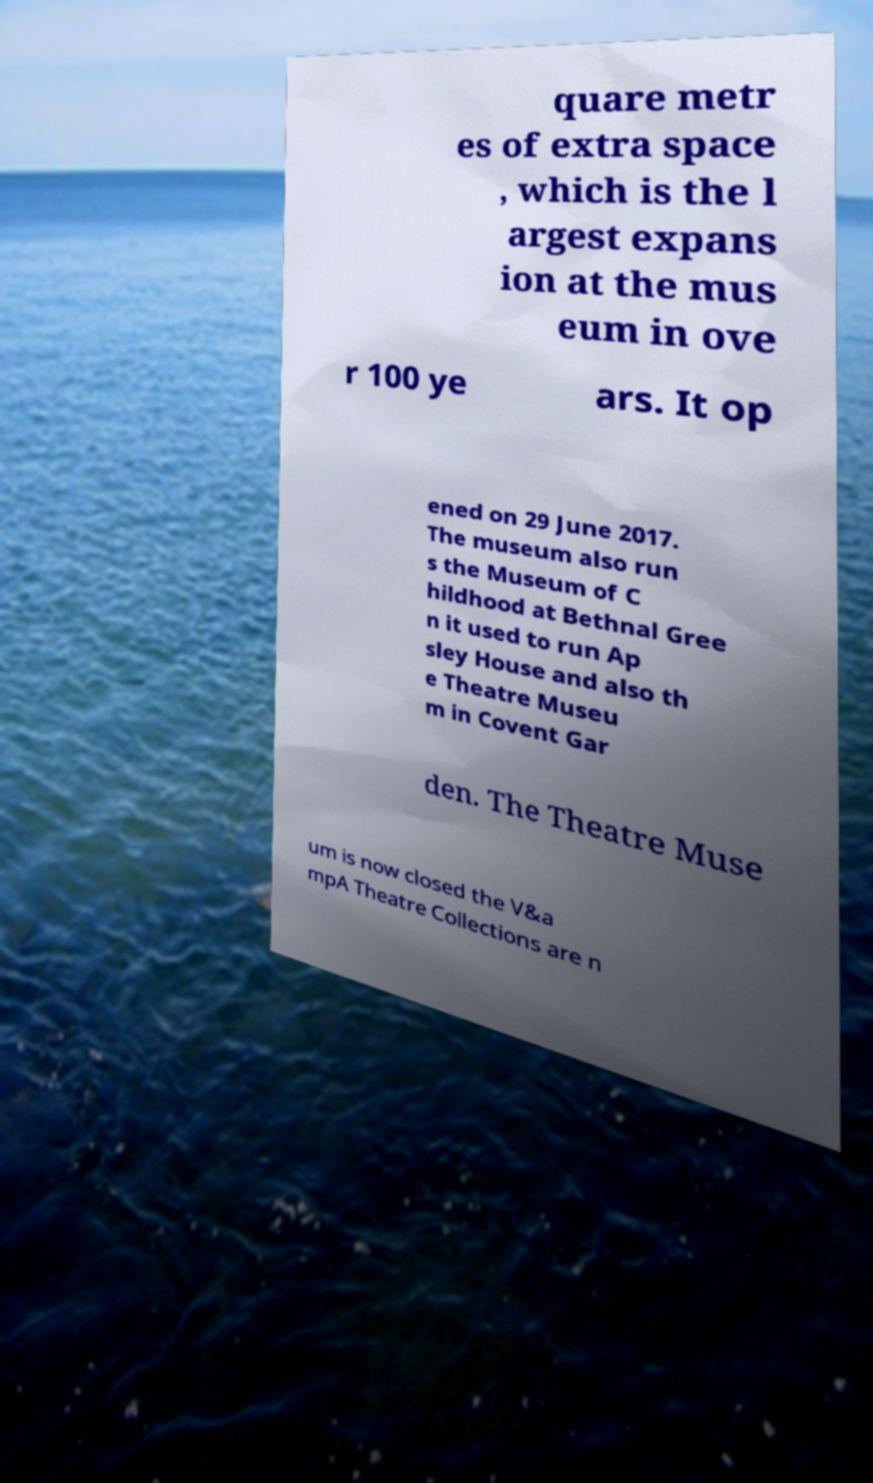Could you assist in decoding the text presented in this image and type it out clearly? quare metr es of extra space , which is the l argest expans ion at the mus eum in ove r 100 ye ars. It op ened on 29 June 2017. The museum also run s the Museum of C hildhood at Bethnal Gree n it used to run Ap sley House and also th e Theatre Museu m in Covent Gar den. The Theatre Muse um is now closed the V&a mpA Theatre Collections are n 